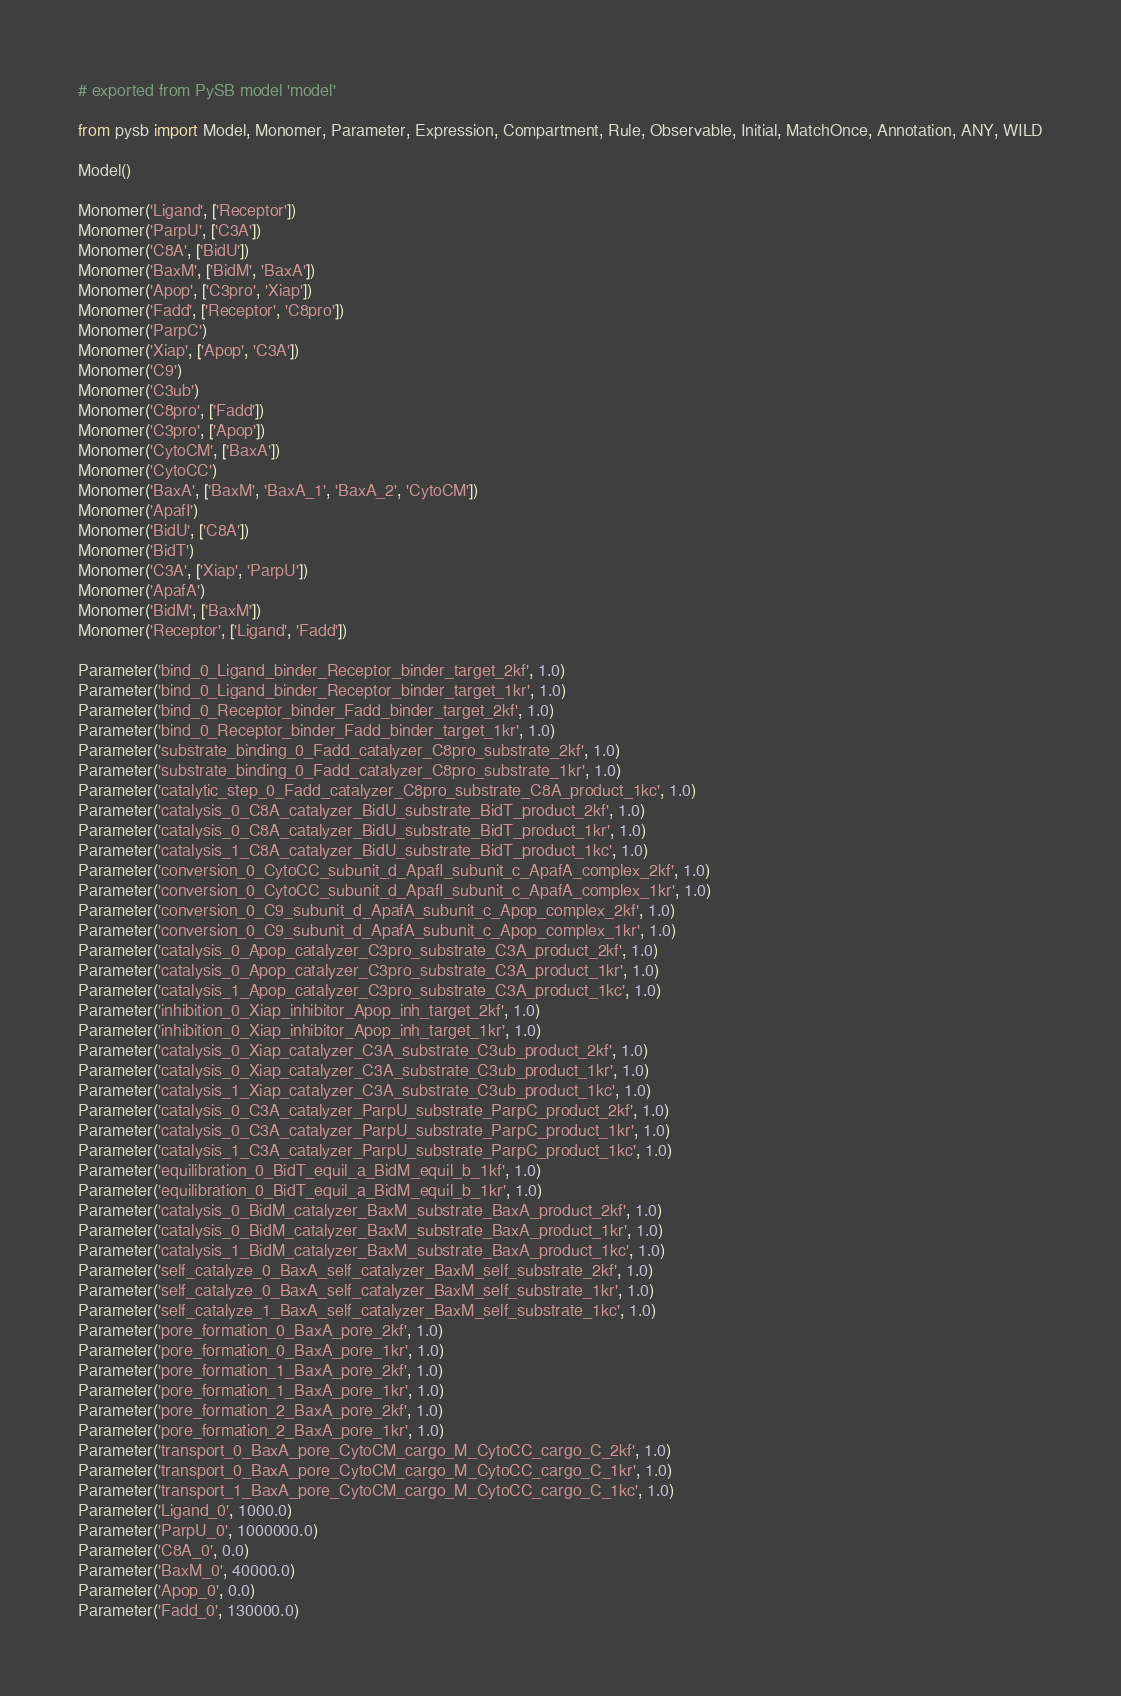<code> <loc_0><loc_0><loc_500><loc_500><_Python_># exported from PySB model 'model'

from pysb import Model, Monomer, Parameter, Expression, Compartment, Rule, Observable, Initial, MatchOnce, Annotation, ANY, WILD

Model()

Monomer('Ligand', ['Receptor'])
Monomer('ParpU', ['C3A'])
Monomer('C8A', ['BidU'])
Monomer('BaxM', ['BidM', 'BaxA'])
Monomer('Apop', ['C3pro', 'Xiap'])
Monomer('Fadd', ['Receptor', 'C8pro'])
Monomer('ParpC')
Monomer('Xiap', ['Apop', 'C3A'])
Monomer('C9')
Monomer('C3ub')
Monomer('C8pro', ['Fadd'])
Monomer('C3pro', ['Apop'])
Monomer('CytoCM', ['BaxA'])
Monomer('CytoCC')
Monomer('BaxA', ['BaxM', 'BaxA_1', 'BaxA_2', 'CytoCM'])
Monomer('ApafI')
Monomer('BidU', ['C8A'])
Monomer('BidT')
Monomer('C3A', ['Xiap', 'ParpU'])
Monomer('ApafA')
Monomer('BidM', ['BaxM'])
Monomer('Receptor', ['Ligand', 'Fadd'])

Parameter('bind_0_Ligand_binder_Receptor_binder_target_2kf', 1.0)
Parameter('bind_0_Ligand_binder_Receptor_binder_target_1kr', 1.0)
Parameter('bind_0_Receptor_binder_Fadd_binder_target_2kf', 1.0)
Parameter('bind_0_Receptor_binder_Fadd_binder_target_1kr', 1.0)
Parameter('substrate_binding_0_Fadd_catalyzer_C8pro_substrate_2kf', 1.0)
Parameter('substrate_binding_0_Fadd_catalyzer_C8pro_substrate_1kr', 1.0)
Parameter('catalytic_step_0_Fadd_catalyzer_C8pro_substrate_C8A_product_1kc', 1.0)
Parameter('catalysis_0_C8A_catalyzer_BidU_substrate_BidT_product_2kf', 1.0)
Parameter('catalysis_0_C8A_catalyzer_BidU_substrate_BidT_product_1kr', 1.0)
Parameter('catalysis_1_C8A_catalyzer_BidU_substrate_BidT_product_1kc', 1.0)
Parameter('conversion_0_CytoCC_subunit_d_ApafI_subunit_c_ApafA_complex_2kf', 1.0)
Parameter('conversion_0_CytoCC_subunit_d_ApafI_subunit_c_ApafA_complex_1kr', 1.0)
Parameter('conversion_0_C9_subunit_d_ApafA_subunit_c_Apop_complex_2kf', 1.0)
Parameter('conversion_0_C9_subunit_d_ApafA_subunit_c_Apop_complex_1kr', 1.0)
Parameter('catalysis_0_Apop_catalyzer_C3pro_substrate_C3A_product_2kf', 1.0)
Parameter('catalysis_0_Apop_catalyzer_C3pro_substrate_C3A_product_1kr', 1.0)
Parameter('catalysis_1_Apop_catalyzer_C3pro_substrate_C3A_product_1kc', 1.0)
Parameter('inhibition_0_Xiap_inhibitor_Apop_inh_target_2kf', 1.0)
Parameter('inhibition_0_Xiap_inhibitor_Apop_inh_target_1kr', 1.0)
Parameter('catalysis_0_Xiap_catalyzer_C3A_substrate_C3ub_product_2kf', 1.0)
Parameter('catalysis_0_Xiap_catalyzer_C3A_substrate_C3ub_product_1kr', 1.0)
Parameter('catalysis_1_Xiap_catalyzer_C3A_substrate_C3ub_product_1kc', 1.0)
Parameter('catalysis_0_C3A_catalyzer_ParpU_substrate_ParpC_product_2kf', 1.0)
Parameter('catalysis_0_C3A_catalyzer_ParpU_substrate_ParpC_product_1kr', 1.0)
Parameter('catalysis_1_C3A_catalyzer_ParpU_substrate_ParpC_product_1kc', 1.0)
Parameter('equilibration_0_BidT_equil_a_BidM_equil_b_1kf', 1.0)
Parameter('equilibration_0_BidT_equil_a_BidM_equil_b_1kr', 1.0)
Parameter('catalysis_0_BidM_catalyzer_BaxM_substrate_BaxA_product_2kf', 1.0)
Parameter('catalysis_0_BidM_catalyzer_BaxM_substrate_BaxA_product_1kr', 1.0)
Parameter('catalysis_1_BidM_catalyzer_BaxM_substrate_BaxA_product_1kc', 1.0)
Parameter('self_catalyze_0_BaxA_self_catalyzer_BaxM_self_substrate_2kf', 1.0)
Parameter('self_catalyze_0_BaxA_self_catalyzer_BaxM_self_substrate_1kr', 1.0)
Parameter('self_catalyze_1_BaxA_self_catalyzer_BaxM_self_substrate_1kc', 1.0)
Parameter('pore_formation_0_BaxA_pore_2kf', 1.0)
Parameter('pore_formation_0_BaxA_pore_1kr', 1.0)
Parameter('pore_formation_1_BaxA_pore_2kf', 1.0)
Parameter('pore_formation_1_BaxA_pore_1kr', 1.0)
Parameter('pore_formation_2_BaxA_pore_2kf', 1.0)
Parameter('pore_formation_2_BaxA_pore_1kr', 1.0)
Parameter('transport_0_BaxA_pore_CytoCM_cargo_M_CytoCC_cargo_C_2kf', 1.0)
Parameter('transport_0_BaxA_pore_CytoCM_cargo_M_CytoCC_cargo_C_1kr', 1.0)
Parameter('transport_1_BaxA_pore_CytoCM_cargo_M_CytoCC_cargo_C_1kc', 1.0)
Parameter('Ligand_0', 1000.0)
Parameter('ParpU_0', 1000000.0)
Parameter('C8A_0', 0.0)
Parameter('BaxM_0', 40000.0)
Parameter('Apop_0', 0.0)
Parameter('Fadd_0', 130000.0)</code> 